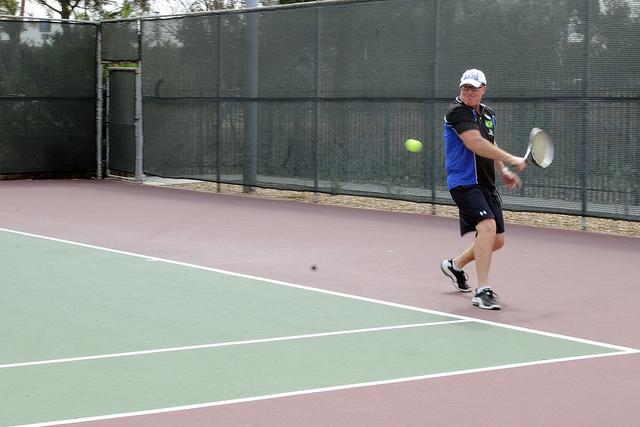What color is the tennis court?
Answer briefly. Green. Is the player going to use a forehand stroke?
Be succinct. No. What color is the tennis ball near the man?
Keep it brief. Yellow. 